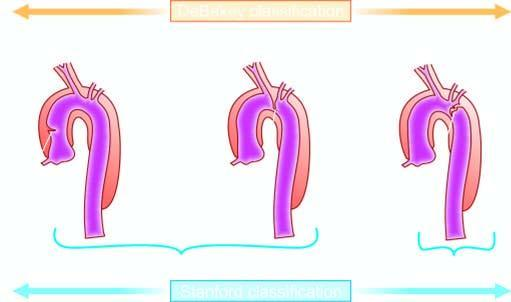what is limited to descending aorta?
Answer the question using a single word or phrase. Stanford type b 